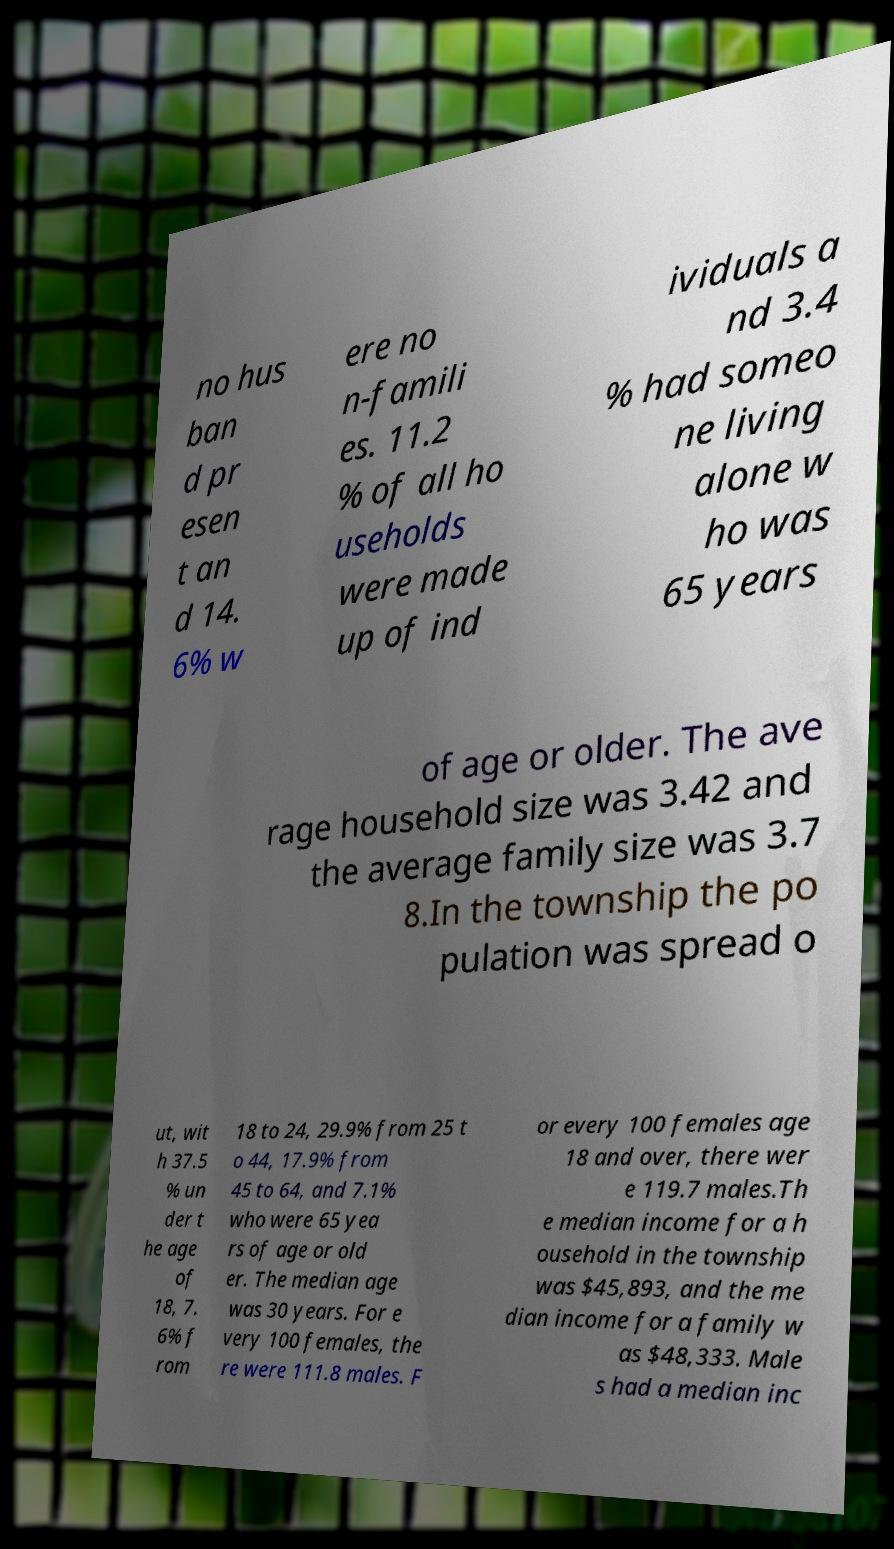Can you read and provide the text displayed in the image?This photo seems to have some interesting text. Can you extract and type it out for me? no hus ban d pr esen t an d 14. 6% w ere no n-famili es. 11.2 % of all ho useholds were made up of ind ividuals a nd 3.4 % had someo ne living alone w ho was 65 years of age or older. The ave rage household size was 3.42 and the average family size was 3.7 8.In the township the po pulation was spread o ut, wit h 37.5 % un der t he age of 18, 7. 6% f rom 18 to 24, 29.9% from 25 t o 44, 17.9% from 45 to 64, and 7.1% who were 65 yea rs of age or old er. The median age was 30 years. For e very 100 females, the re were 111.8 males. F or every 100 females age 18 and over, there wer e 119.7 males.Th e median income for a h ousehold in the township was $45,893, and the me dian income for a family w as $48,333. Male s had a median inc 